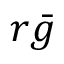Convert formula to latex. <formula><loc_0><loc_0><loc_500><loc_500>r { \bar { g } }</formula> 